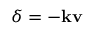<formula> <loc_0><loc_0><loc_500><loc_500>\delta = - k v</formula> 